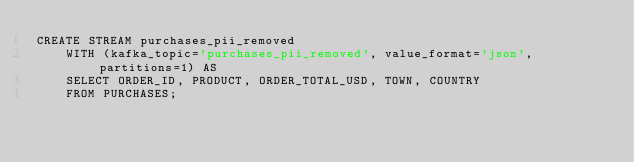<code> <loc_0><loc_0><loc_500><loc_500><_SQL_>CREATE STREAM purchases_pii_removed
    WITH (kafka_topic='purchases_pii_removed', value_format='json', partitions=1) AS
    SELECT ORDER_ID, PRODUCT, ORDER_TOTAL_USD, TOWN, COUNTRY
    FROM PURCHASES;
</code> 